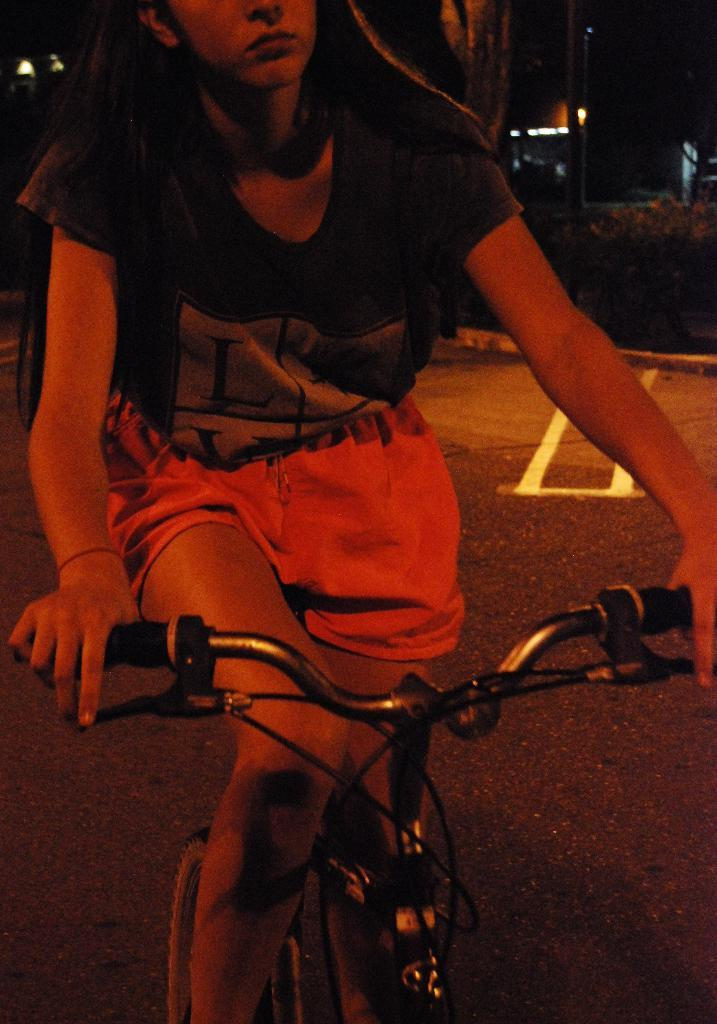Who is the main subject in the image? A: There is a woman in the image. What is the woman wearing? The woman is wearing a black t-shirt. What activity is the woman engaged in? The woman is riding a bicycle. Where is the bicycle located? The bicycle is on a road. What can be seen in the background of the image? There is a building and trees visible in the background. How would you describe the lighting in the image? The image is taken in a dark environment. What type of head can be seen on the cup in the image? There is no cup or head present in the image; it features a woman riding a bicycle on a road. What kind of structure is supporting the woman while she rides the bicycle in the image? The woman is riding the bicycle independently, and there is no supporting structure visible in the image. 